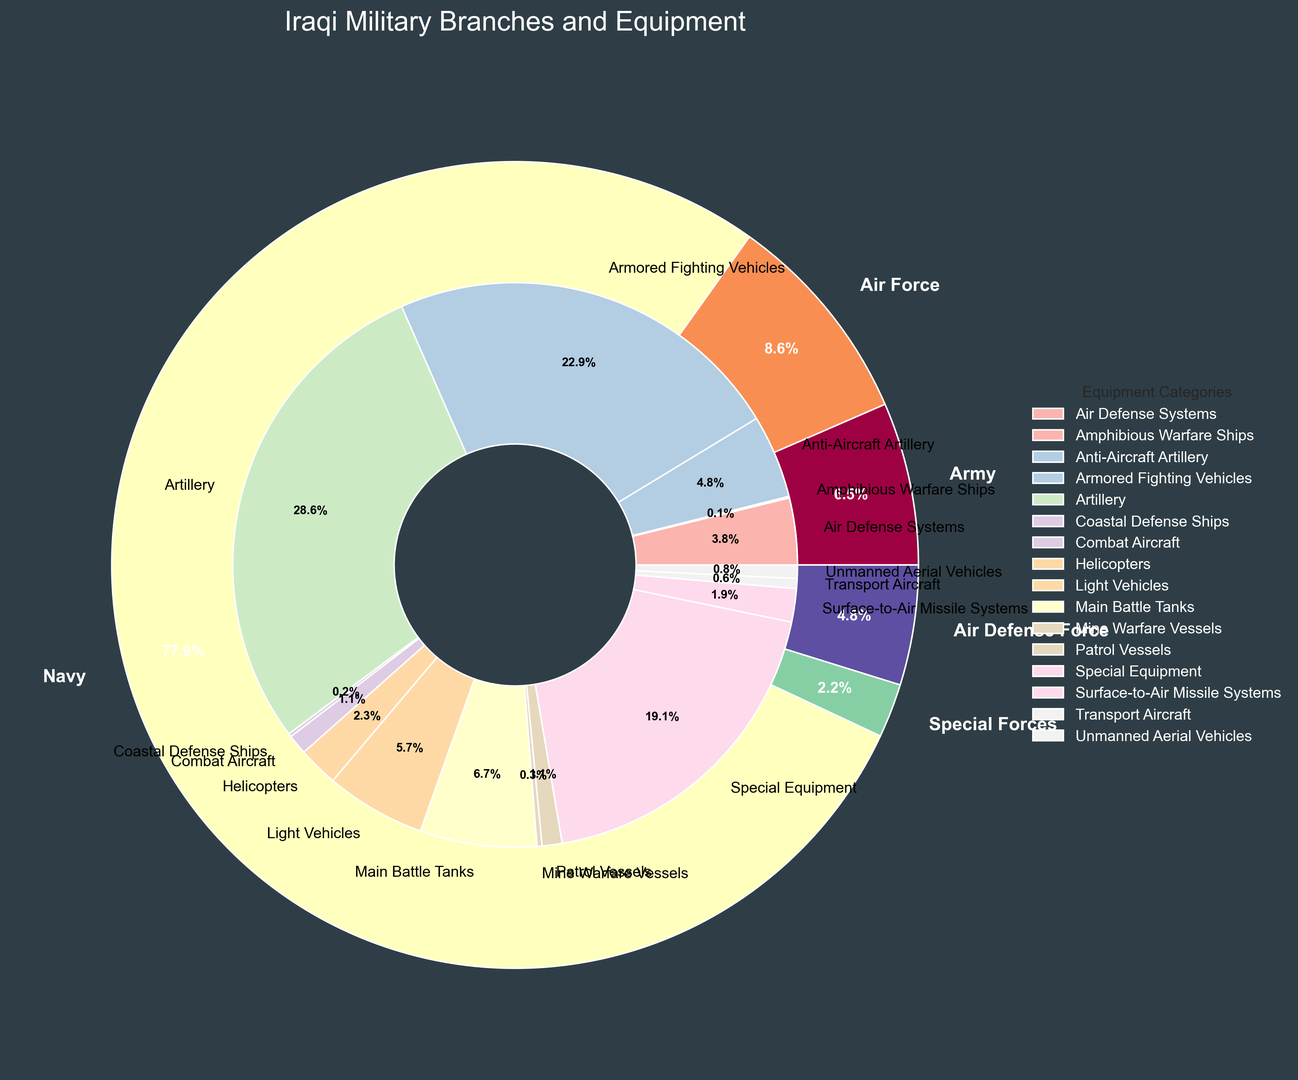What branch has the largest share of personnel? The Army has the largest share of personnel with 180,000 members compared to other branches. This can be visually confirmed by the largest segment labeled "Army" in the outer pie chart.
Answer: Army Which category contributes the most to the inner pie chart in terms of equipment? The inner pie chart shows several equipment categories, and Artillery stands out as the largest segment. Summing the values, Artillery has 1,500 units, which is the highest among all categories represented.
Answer: Artillery Compare the total number of personnel in the Air Force and the Air Defense Force. Which one is higher and by how much? The Air Force has 20,000 personnel while the Air Defense Force has 15,000. To find the difference, subtract 15,000 from 20,000, which equals 5,000.
Answer: Air Force by 5,000 What percentage of the total personnel is in Special Forces? The pie chart shows that Special Forces have 10,000 personnel. Summing all personnel: 180,000 (Army) + 20,000 (Air Force) + 5,000 (Navy) + 10,000 (Special Forces) + 15,000 (Air Defense Force) results in a total of 230,000 personnel. Therefore, Special Forces are (10,000/230,000) * 100 ≈ 4.3% of the total.
Answer: Approximately 4.3% Which branch has the least amount of personnel, and how does its share compare to the Army's in percentage terms? The Navy has the least personnel with 5,000 members. The Army has 180,000 personnel. The percentage for the Navy is (5,000/230,000)*100 ≈ 2.2%. The Army's percentage is (180,000/230,000)*100 ≈ 78.3%. Comparatively, the Navy has far fewer personnel than the Army.
Answer: Navy, Army has approximately 76.1% more Regarding non-personnel categories in the Army, which equipment category has the smallest number? Reviewing the inner pie chart for the Army, the category with the smallest number is Air Defense Systems with 200 units. This is visually the smallest segment among Army equipment.
Answer: Air Defense Systems How does the number of Combat Aircraft in the Air Force compare to the total number of armored vehicles (Main Battle Tanks and Armored Fighting Vehicles) in the Army? The Air Force has 60 Combat Aircraft. The total number of armored vehicles in the Army is 350 (Main Battle Tanks) + 1200 (Armored Fighting Vehicles) = 1550. Therefore, there are significantly more armored vehicles in the Army compared to Combat Aircraft in the Air Force.
Answer: Army has 1490 more armored vehicles Calculate the total percentage share of the remaining military branches aside from the Army. The total personnel are 230,000. The Army has 180,000 personnel, so the remaining branches have 230,000 - 180,000 = 50,000 personnel. The percentage is (50,000/230,000)*100 ≈ 21.7%.
Answer: 21.7% Which category recorded in the inner pie chart represents light vehicles, and to which branch does it belong? The category "Light Vehicles" is represents a segment in the inner pie chart. This belongs to the Special Forces and visually it can be seen as a segment labeled "Light Vehicles."
Answer: Special Forces 